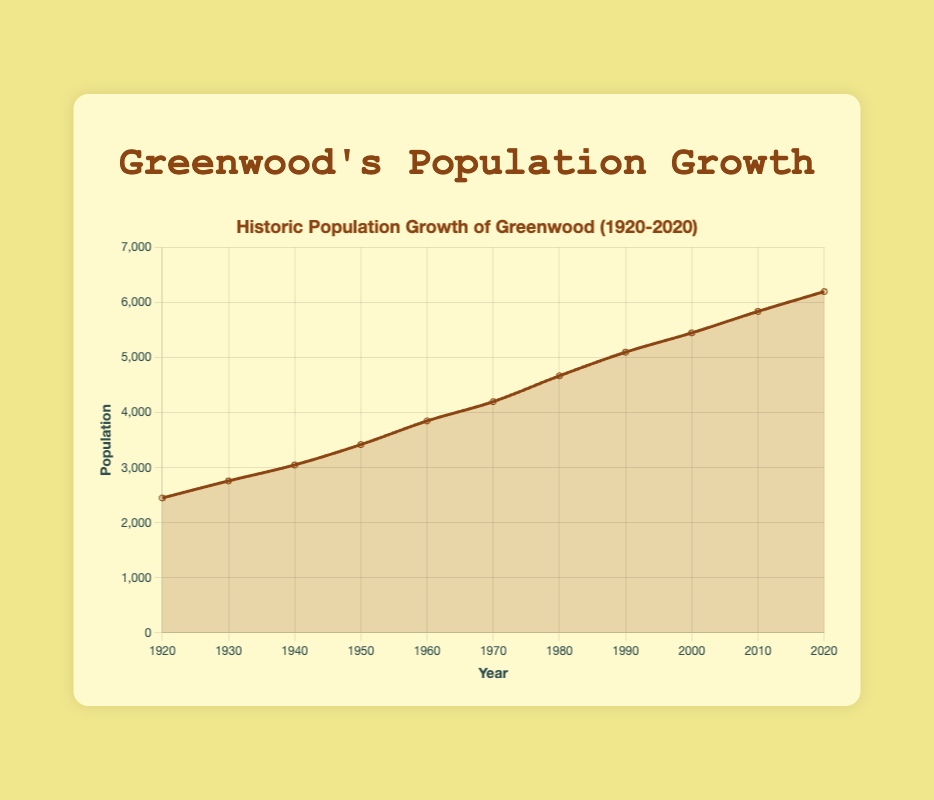What's the population increase from 1920 to 2020? To find the population increase, subtract the 1920 population (2450) from the 2020 population (6200). 6200 - 2450 = 3750
Answer: 3750 What was the population of Greenwood in 1980? Look at the data point corresponding to the year 1980. The population was 4670.
Answer: 4670 During which decade did Greenwood experience the highest population growth? Calculate the population growth for each decade by subtracting the earlier year's population from the later year's population. Compare the differences: 
1930-1920: 2760-2450=310 
1940-1930: 3050-2760=290 
1950-1940: 3420-3050=370 
1960-1950: 3850-3420=430 
1970-1960: 4200-3850=350 
1980-1970: 4670-4200=470 
1990-1980: 5100-4670=430 
2000-1990: 5450-5100=350 
2010-2000: 5840-5450=390  
2020-2010: 6200-5840=360
Answer: 1980-1990 (470) Which year had the lowest population? By inspecting the data, the year with the lowest population is 1920 with 2450 people.
Answer: 1920 What is the average population in Greenwood across all the years listed? Add up all the population values and divide by the number of years: (2450 + 2760 + 3050 + 3420 + 3850 + 4200 + 4670 + 5100 + 5450 + 5840 + 6200) / 11. Total population is 51090. 51090 / 11 = 4644.5
Answer: 4644.5 How does the population in 2010 compare to 1990? Subtract the 1990 population (5100) from the 2010 population (5840) to find the difference: 5840 - 5100 = 740. The population in 2010 is higher by 740 people.
Answer: 740 higher What is the median population within the dataset? Arrange the populations in ascending order: 2450, 2760, 3050, 3420, 3850, 4200, 4670, 5100, 5450, 5840, 6200. The middle value, 7th value in a sorted list, is 4670.
Answer: 4670 What is the trend of population growth from 1920 to 2020? By observing the line plot, the population consistently increases over the years from 1920 to 2020. The growth trend is positive.
Answer: Positive growth From 2000 to 2020, did the population grow more than from 1980 to 2000? Determine the population increases for both periods: 
2000-2020: 6200 - 5450 = 750 
1980-2000: 5450 - 4670 = 780. 
No, population grew less in 2000-2020 compared to 1980-2000.
Answer: No 